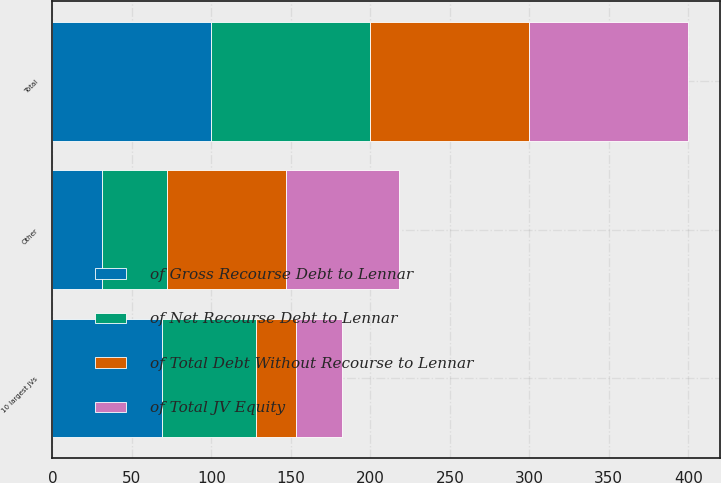Convert chart. <chart><loc_0><loc_0><loc_500><loc_500><stacked_bar_chart><ecel><fcel>10 largest JVs<fcel>Other<fcel>Total<nl><fcel>of Gross Recourse Debt to Lennar<fcel>69<fcel>31<fcel>100<nl><fcel>of Total JV Equity<fcel>29<fcel>71<fcel>100<nl><fcel>of Total Debt Without Recourse to Lennar<fcel>25<fcel>75<fcel>100<nl><fcel>of Net Recourse Debt to Lennar<fcel>59<fcel>41<fcel>100<nl></chart> 